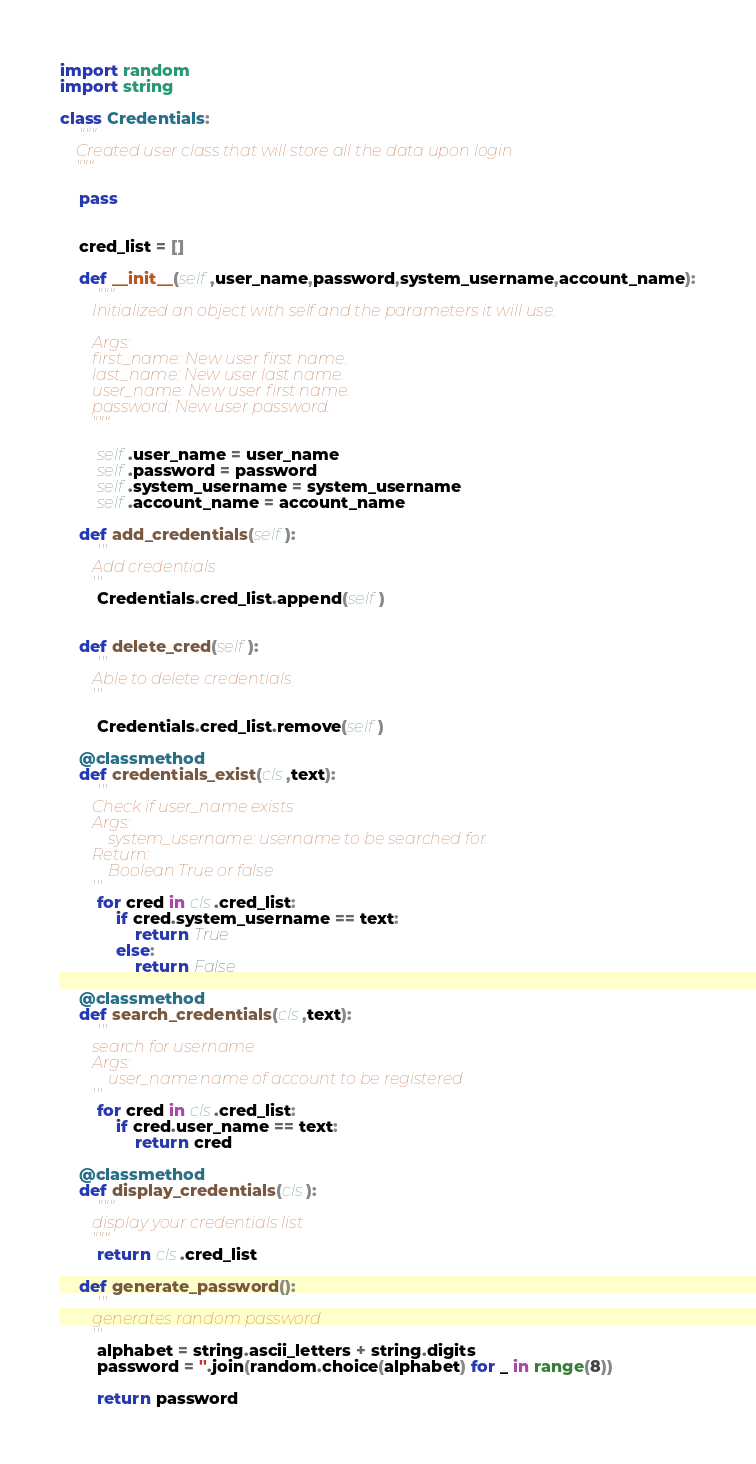<code> <loc_0><loc_0><loc_500><loc_500><_Python_>import random
import string

class Credentials:
    """
    Created user class that will store all the data upon login
    """

    pass


    cred_list = []

    def __init__(self,user_name,password,system_username,account_name):
        """
        Initialized an object with self and the parameters it will use.
        
        Args:
        first_name: New user first name.
        last_name: New user last name.
        user_name: New user first name.
        password: New user password.
        """    

        self.user_name = user_name
        self.password = password
        self.system_username = system_username
        self.account_name = account_name
 
    def add_credentials(self):
        '''
        Add credentials
        '''
        Credentials.cred_list.append(self)


    def delete_cred(self):
        '''
        Able to delete credentials
        '''

        Credentials.cred_list.remove(self)

    @classmethod
    def credentials_exist(cls,text):
        '''
        Check if user_name exists
        Args:
            system_username: username to be searched for.
        Return:
            Boolean True or false
        '''
        for cred in cls.cred_list:
            if cred.system_username == text:
                return True
            else:
                return False 

    @classmethod
    def search_credentials(cls,text):
        '''
        search for username
        Args:
            user_name:name of account to be registered
        '''
        for cred in cls.cred_list:
            if cred.user_name == text:
                return cred

    @classmethod
    def display_credentials(cls):
        """
        display your credentials list
        """
        return cls.cred_list

    def generate_password():
        '''
        generates random password
        '''
        alphabet = string.ascii_letters + string.digits
        password = ''.join(random.choice(alphabet) for _ in range(8))

        return password</code> 